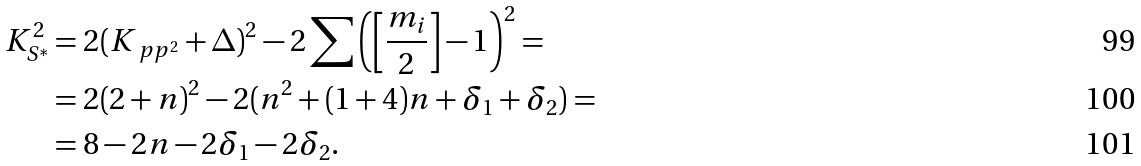Convert formula to latex. <formula><loc_0><loc_0><loc_500><loc_500>K _ { S ^ { \ast } } ^ { 2 } & = 2 ( K _ { \ p p ^ { 2 } } + \Delta ) ^ { 2 } - 2 \sum \left ( \left [ \frac { m _ { i } } 2 \right ] - 1 \right ) ^ { 2 } = \\ & = 2 ( 2 + n ) ^ { 2 } - 2 ( n ^ { 2 } + ( 1 + 4 ) n + \delta _ { 1 } + \delta _ { 2 } ) = \\ & = 8 - 2 n - 2 \delta _ { 1 } - 2 \delta _ { 2 } .</formula> 